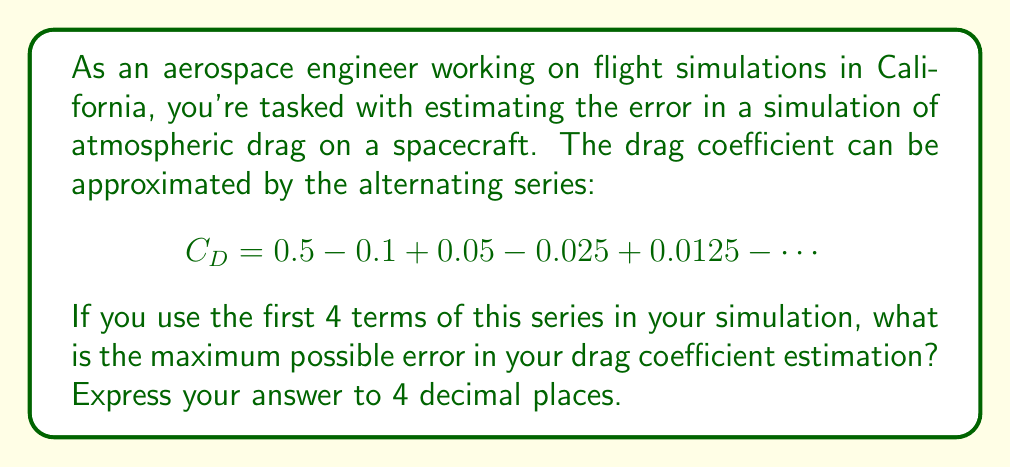Show me your answer to this math problem. To solve this problem, we need to understand the properties of alternating series and how to estimate their error. Let's approach this step-by-step:

1) First, let's identify the general term of the series. We can see that each term is half the absolute value of the previous term, alternating in sign. We can write the general term as:

   $$a_n = (-1)^{n+1} \cdot 0.5 \cdot (0.5)^{n-1}$$

2) For an alternating series where the absolute value of terms decreases and approaches zero, the maximum error is bounded by the absolute value of the first neglected term.

3) In this case, we're using the first 4 terms, so the first neglected term is the 5th term. Let's calculate it:

   $$|a_5| = 0.5 \cdot (0.5)^{5-1} = 0.5 \cdot (0.5)^4 = 0.5 \cdot 0.0625 = 0.03125$$

4) Therefore, the maximum possible error is 0.03125.

5) Rounding to 4 decimal places, we get 0.0313.

This error estimation is crucial in aerospace engineering as it helps determine the accuracy of flight simulations, which is vital for mission planning and safety considerations.
Answer: 0.0313 